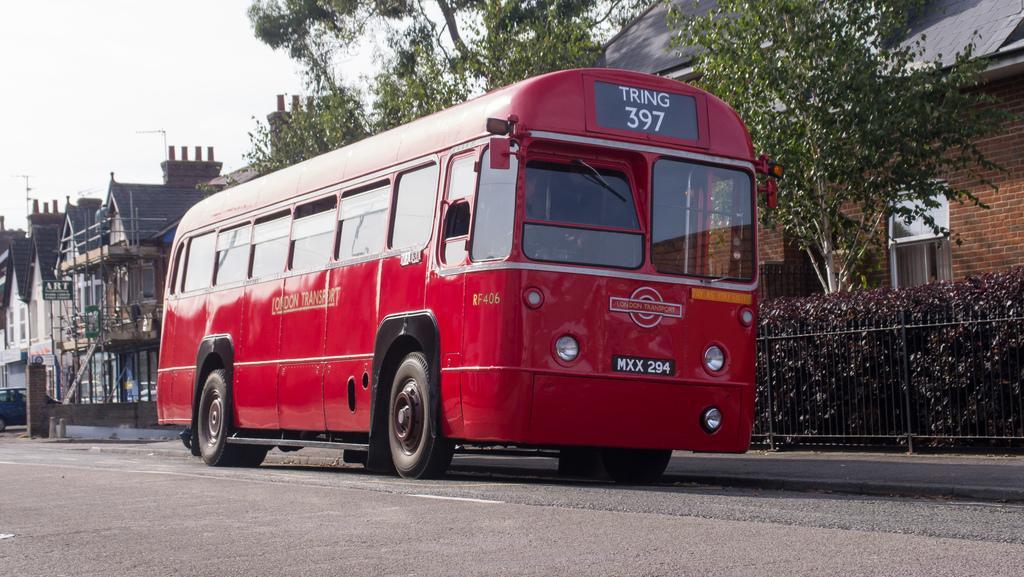How would you summarize this image in a sentence or two? Here in this picture we can see a bus present on the road and beside that we can see railing present and we can see bushes, plants and trees present and we can also see buildings and houses present and we can see the sky is cloudy. 